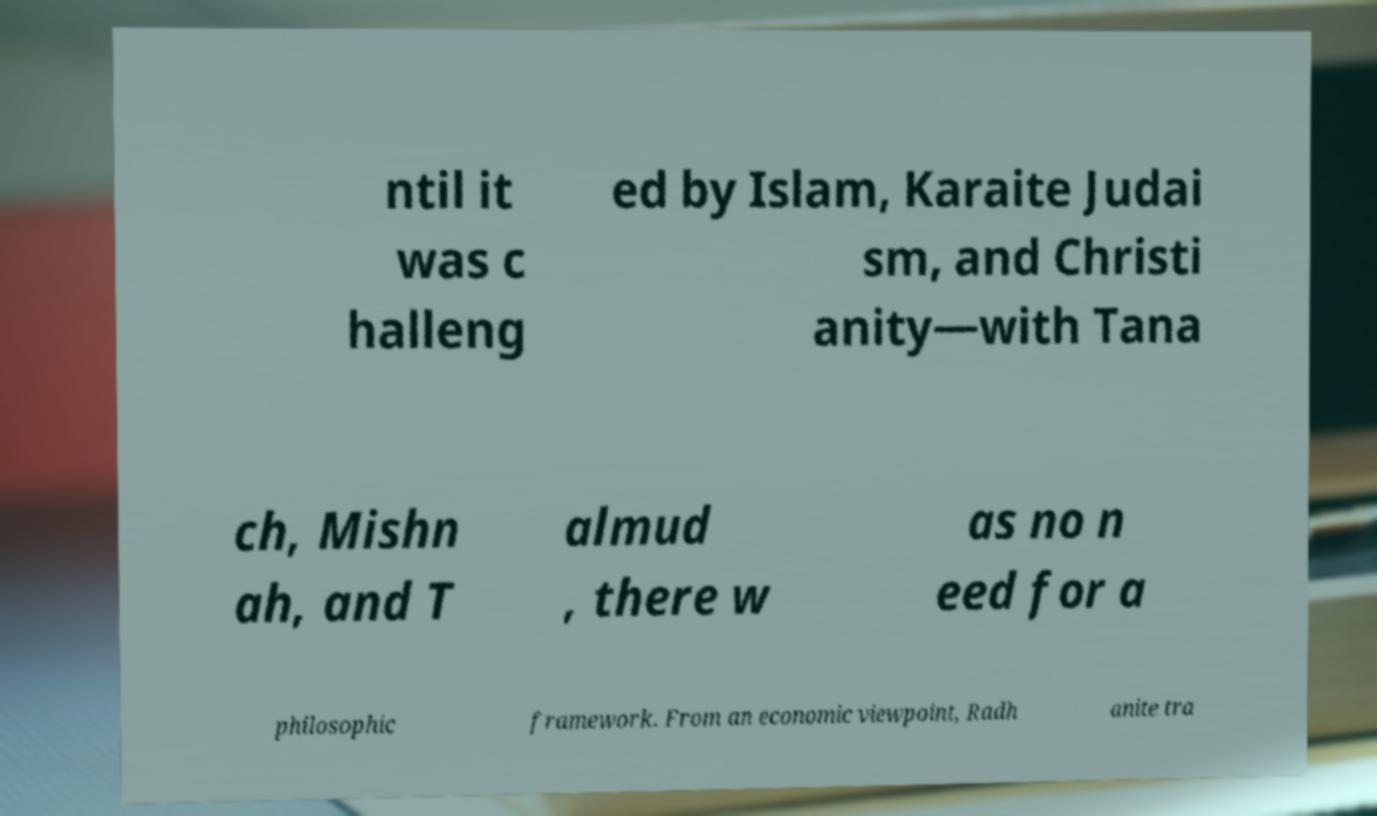There's text embedded in this image that I need extracted. Can you transcribe it verbatim? ntil it was c halleng ed by Islam, Karaite Judai sm, and Christi anity—with Tana ch, Mishn ah, and T almud , there w as no n eed for a philosophic framework. From an economic viewpoint, Radh anite tra 